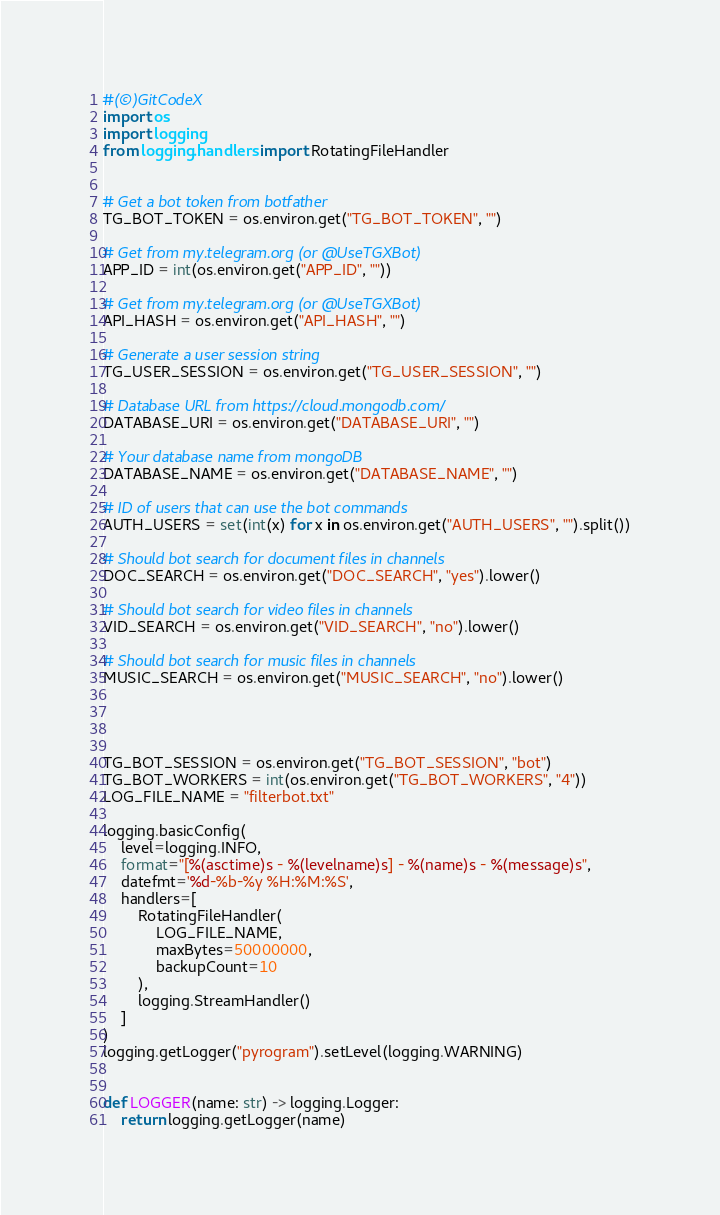<code> <loc_0><loc_0><loc_500><loc_500><_Python_>#(©)GitCodeX
import os
import logging
from logging.handlers import RotatingFileHandler


# Get a bot token from botfather
TG_BOT_TOKEN = os.environ.get("TG_BOT_TOKEN", "")

# Get from my.telegram.org (or @UseTGXBot)
APP_ID = int(os.environ.get("APP_ID", ""))

# Get from my.telegram.org (or @UseTGXBot)
API_HASH = os.environ.get("API_HASH", "")

# Generate a user session string 
TG_USER_SESSION = os.environ.get("TG_USER_SESSION", "")

# Database URL from https://cloud.mongodb.com/
DATABASE_URI = os.environ.get("DATABASE_URI", "")

# Your database name from mongoDB
DATABASE_NAME = os.environ.get("DATABASE_NAME", "")

# ID of users that can use the bot commands
AUTH_USERS = set(int(x) for x in os.environ.get("AUTH_USERS", "").split())

# Should bot search for document files in channels
DOC_SEARCH = os.environ.get("DOC_SEARCH", "yes").lower()

# Should bot search for video files in channels
VID_SEARCH = os.environ.get("VID_SEARCH", "no").lower()

# Should bot search for music files in channels
MUSIC_SEARCH = os.environ.get("MUSIC_SEARCH", "no").lower()




TG_BOT_SESSION = os.environ.get("TG_BOT_SESSION", "bot")
TG_BOT_WORKERS = int(os.environ.get("TG_BOT_WORKERS", "4"))
LOG_FILE_NAME = "filterbot.txt"

logging.basicConfig(
    level=logging.INFO,
    format="[%(asctime)s - %(levelname)s] - %(name)s - %(message)s",
    datefmt='%d-%b-%y %H:%M:%S',
    handlers=[
        RotatingFileHandler(
            LOG_FILE_NAME,
            maxBytes=50000000,
            backupCount=10
        ),
        logging.StreamHandler()
    ]
)
logging.getLogger("pyrogram").setLevel(logging.WARNING)


def LOGGER(name: str) -> logging.Logger:
    return logging.getLogger(name)
</code> 